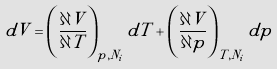Convert formula to latex. <formula><loc_0><loc_0><loc_500><loc_500>d V = \left ( \frac { \partial V } { \partial T } \right ) _ { p , N _ { i } } d T + \left ( \frac { \partial V } { \partial p } \right ) _ { T , N _ { i } } d p</formula> 